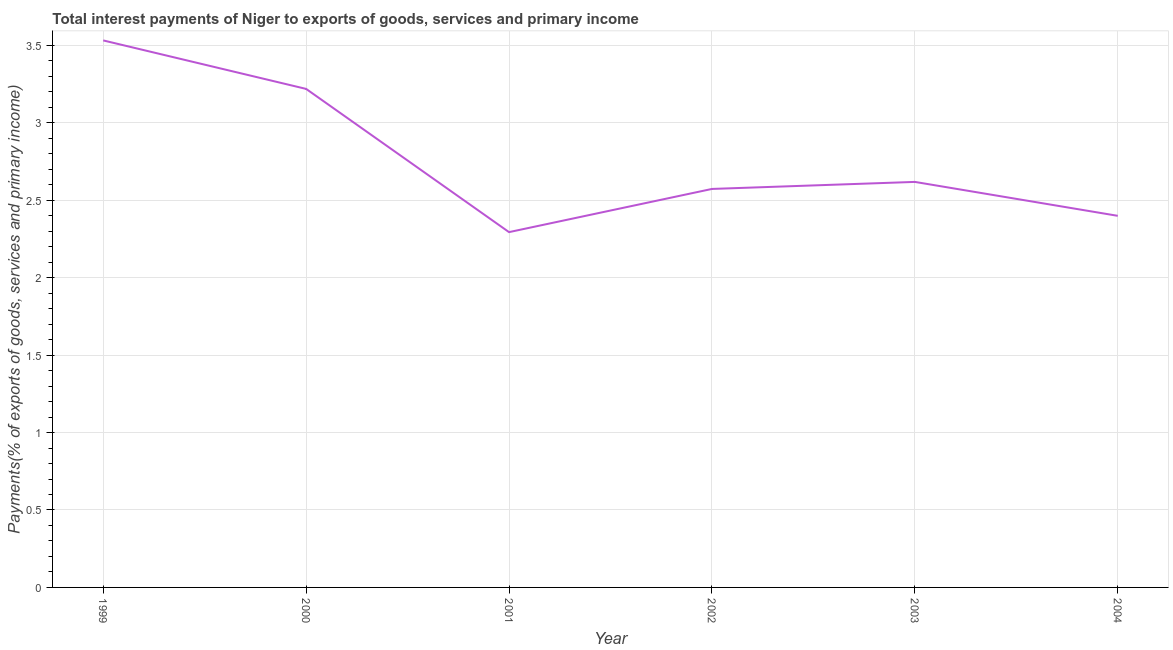What is the total interest payments on external debt in 2000?
Your answer should be compact. 3.22. Across all years, what is the maximum total interest payments on external debt?
Your answer should be very brief. 3.53. Across all years, what is the minimum total interest payments on external debt?
Provide a succinct answer. 2.29. In which year was the total interest payments on external debt maximum?
Ensure brevity in your answer.  1999. In which year was the total interest payments on external debt minimum?
Your response must be concise. 2001. What is the sum of the total interest payments on external debt?
Your answer should be very brief. 16.64. What is the difference between the total interest payments on external debt in 2001 and 2004?
Your answer should be very brief. -0.11. What is the average total interest payments on external debt per year?
Provide a succinct answer. 2.77. What is the median total interest payments on external debt?
Your answer should be compact. 2.6. In how many years, is the total interest payments on external debt greater than 1.6 %?
Provide a succinct answer. 6. What is the ratio of the total interest payments on external debt in 1999 to that in 2004?
Provide a succinct answer. 1.47. Is the total interest payments on external debt in 2001 less than that in 2004?
Offer a very short reply. Yes. What is the difference between the highest and the second highest total interest payments on external debt?
Ensure brevity in your answer.  0.31. Is the sum of the total interest payments on external debt in 2000 and 2003 greater than the maximum total interest payments on external debt across all years?
Offer a very short reply. Yes. What is the difference between the highest and the lowest total interest payments on external debt?
Your response must be concise. 1.24. Does the total interest payments on external debt monotonically increase over the years?
Your response must be concise. No. What is the difference between two consecutive major ticks on the Y-axis?
Provide a short and direct response. 0.5. Does the graph contain any zero values?
Your answer should be compact. No. Does the graph contain grids?
Provide a short and direct response. Yes. What is the title of the graph?
Make the answer very short. Total interest payments of Niger to exports of goods, services and primary income. What is the label or title of the X-axis?
Offer a terse response. Year. What is the label or title of the Y-axis?
Keep it short and to the point. Payments(% of exports of goods, services and primary income). What is the Payments(% of exports of goods, services and primary income) in 1999?
Provide a short and direct response. 3.53. What is the Payments(% of exports of goods, services and primary income) in 2000?
Provide a succinct answer. 3.22. What is the Payments(% of exports of goods, services and primary income) in 2001?
Make the answer very short. 2.29. What is the Payments(% of exports of goods, services and primary income) of 2002?
Your response must be concise. 2.57. What is the Payments(% of exports of goods, services and primary income) in 2003?
Your answer should be very brief. 2.62. What is the Payments(% of exports of goods, services and primary income) of 2004?
Offer a very short reply. 2.4. What is the difference between the Payments(% of exports of goods, services and primary income) in 1999 and 2000?
Give a very brief answer. 0.31. What is the difference between the Payments(% of exports of goods, services and primary income) in 1999 and 2001?
Your response must be concise. 1.24. What is the difference between the Payments(% of exports of goods, services and primary income) in 1999 and 2002?
Your response must be concise. 0.96. What is the difference between the Payments(% of exports of goods, services and primary income) in 1999 and 2003?
Offer a terse response. 0.91. What is the difference between the Payments(% of exports of goods, services and primary income) in 1999 and 2004?
Provide a short and direct response. 1.13. What is the difference between the Payments(% of exports of goods, services and primary income) in 2000 and 2001?
Provide a succinct answer. 0.92. What is the difference between the Payments(% of exports of goods, services and primary income) in 2000 and 2002?
Provide a succinct answer. 0.65. What is the difference between the Payments(% of exports of goods, services and primary income) in 2000 and 2003?
Your response must be concise. 0.6. What is the difference between the Payments(% of exports of goods, services and primary income) in 2000 and 2004?
Give a very brief answer. 0.82. What is the difference between the Payments(% of exports of goods, services and primary income) in 2001 and 2002?
Ensure brevity in your answer.  -0.28. What is the difference between the Payments(% of exports of goods, services and primary income) in 2001 and 2003?
Your answer should be very brief. -0.32. What is the difference between the Payments(% of exports of goods, services and primary income) in 2001 and 2004?
Keep it short and to the point. -0.11. What is the difference between the Payments(% of exports of goods, services and primary income) in 2002 and 2003?
Give a very brief answer. -0.05. What is the difference between the Payments(% of exports of goods, services and primary income) in 2002 and 2004?
Offer a terse response. 0.17. What is the difference between the Payments(% of exports of goods, services and primary income) in 2003 and 2004?
Your response must be concise. 0.22. What is the ratio of the Payments(% of exports of goods, services and primary income) in 1999 to that in 2000?
Make the answer very short. 1.1. What is the ratio of the Payments(% of exports of goods, services and primary income) in 1999 to that in 2001?
Provide a succinct answer. 1.54. What is the ratio of the Payments(% of exports of goods, services and primary income) in 1999 to that in 2002?
Your answer should be compact. 1.37. What is the ratio of the Payments(% of exports of goods, services and primary income) in 1999 to that in 2003?
Ensure brevity in your answer.  1.35. What is the ratio of the Payments(% of exports of goods, services and primary income) in 1999 to that in 2004?
Give a very brief answer. 1.47. What is the ratio of the Payments(% of exports of goods, services and primary income) in 2000 to that in 2001?
Offer a terse response. 1.4. What is the ratio of the Payments(% of exports of goods, services and primary income) in 2000 to that in 2002?
Keep it short and to the point. 1.25. What is the ratio of the Payments(% of exports of goods, services and primary income) in 2000 to that in 2003?
Give a very brief answer. 1.23. What is the ratio of the Payments(% of exports of goods, services and primary income) in 2000 to that in 2004?
Provide a short and direct response. 1.34. What is the ratio of the Payments(% of exports of goods, services and primary income) in 2001 to that in 2002?
Ensure brevity in your answer.  0.89. What is the ratio of the Payments(% of exports of goods, services and primary income) in 2001 to that in 2003?
Ensure brevity in your answer.  0.88. What is the ratio of the Payments(% of exports of goods, services and primary income) in 2001 to that in 2004?
Your answer should be compact. 0.96. What is the ratio of the Payments(% of exports of goods, services and primary income) in 2002 to that in 2003?
Keep it short and to the point. 0.98. What is the ratio of the Payments(% of exports of goods, services and primary income) in 2002 to that in 2004?
Your answer should be very brief. 1.07. What is the ratio of the Payments(% of exports of goods, services and primary income) in 2003 to that in 2004?
Ensure brevity in your answer.  1.09. 